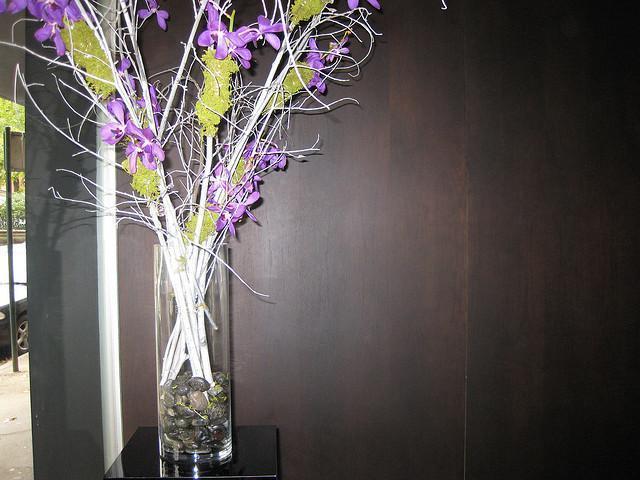How many kinds of flower are in the vase?
Give a very brief answer. 2. How many people are shown?
Give a very brief answer. 0. 